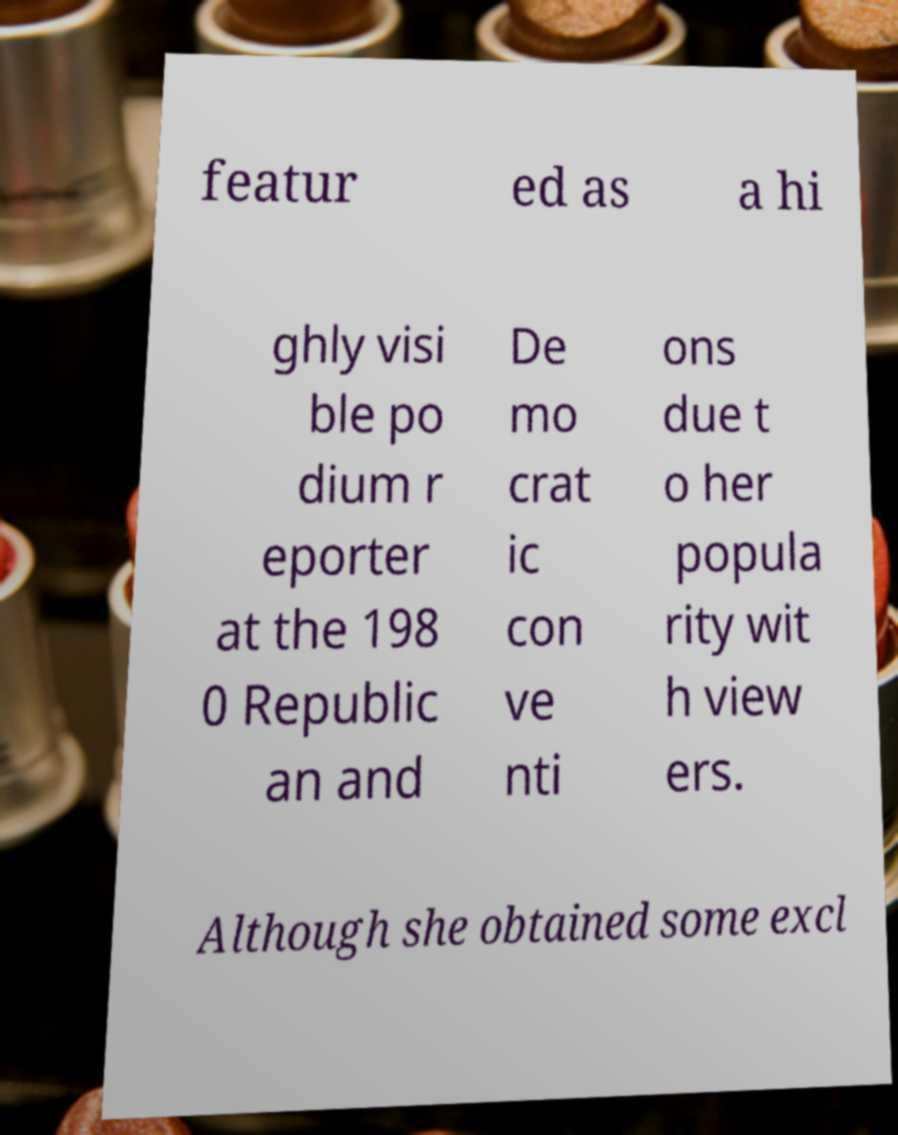For documentation purposes, I need the text within this image transcribed. Could you provide that? featur ed as a hi ghly visi ble po dium r eporter at the 198 0 Republic an and De mo crat ic con ve nti ons due t o her popula rity wit h view ers. Although she obtained some excl 